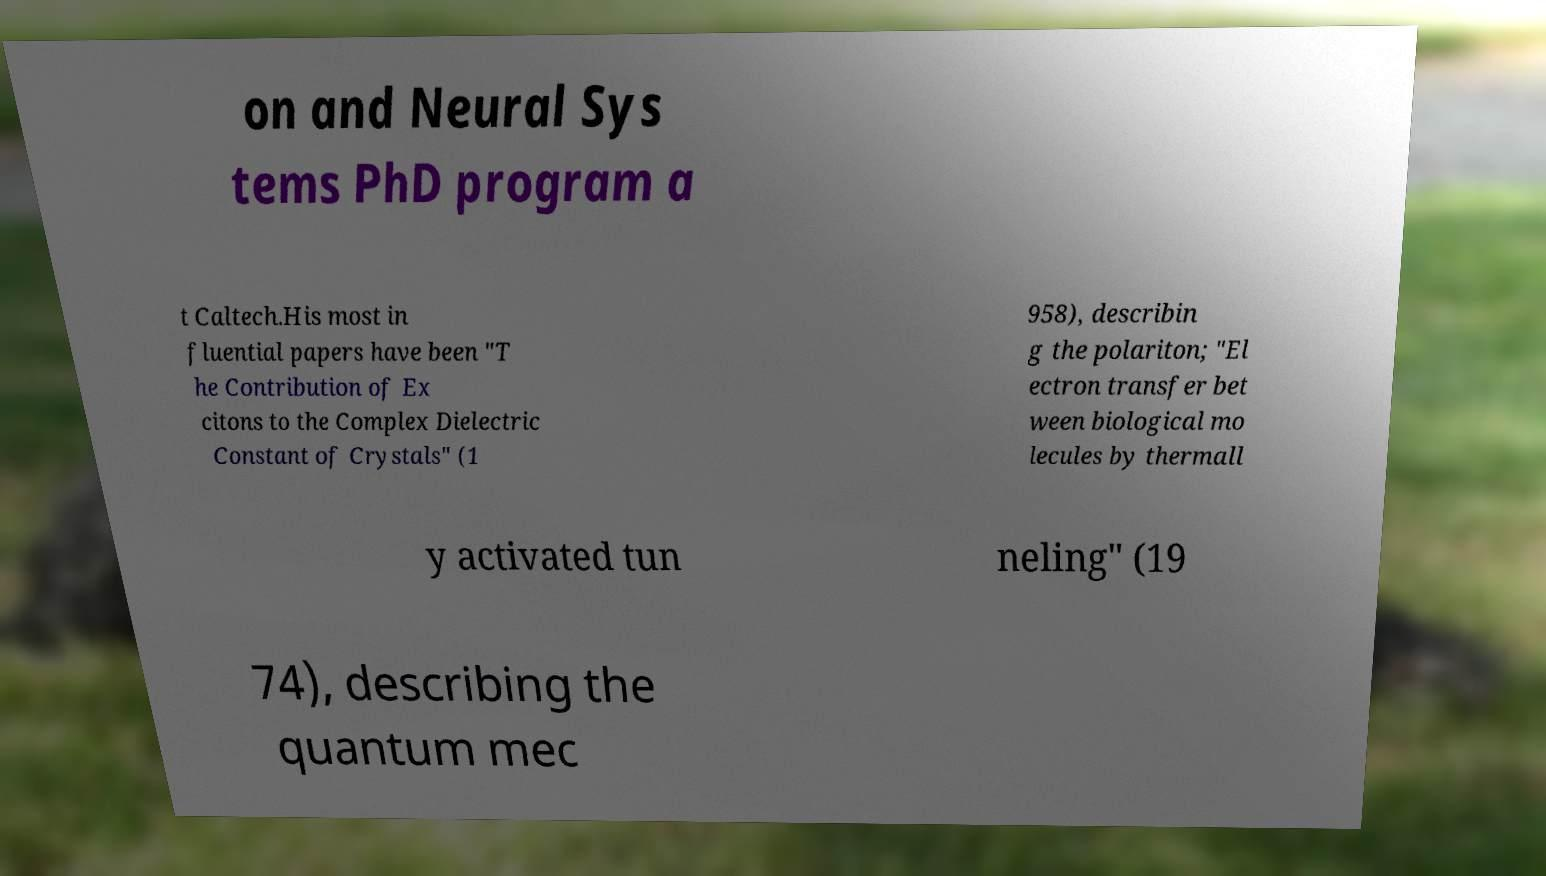There's text embedded in this image that I need extracted. Can you transcribe it verbatim? on and Neural Sys tems PhD program a t Caltech.His most in fluential papers have been "T he Contribution of Ex citons to the Complex Dielectric Constant of Crystals" (1 958), describin g the polariton; "El ectron transfer bet ween biological mo lecules by thermall y activated tun neling" (19 74), describing the quantum mec 